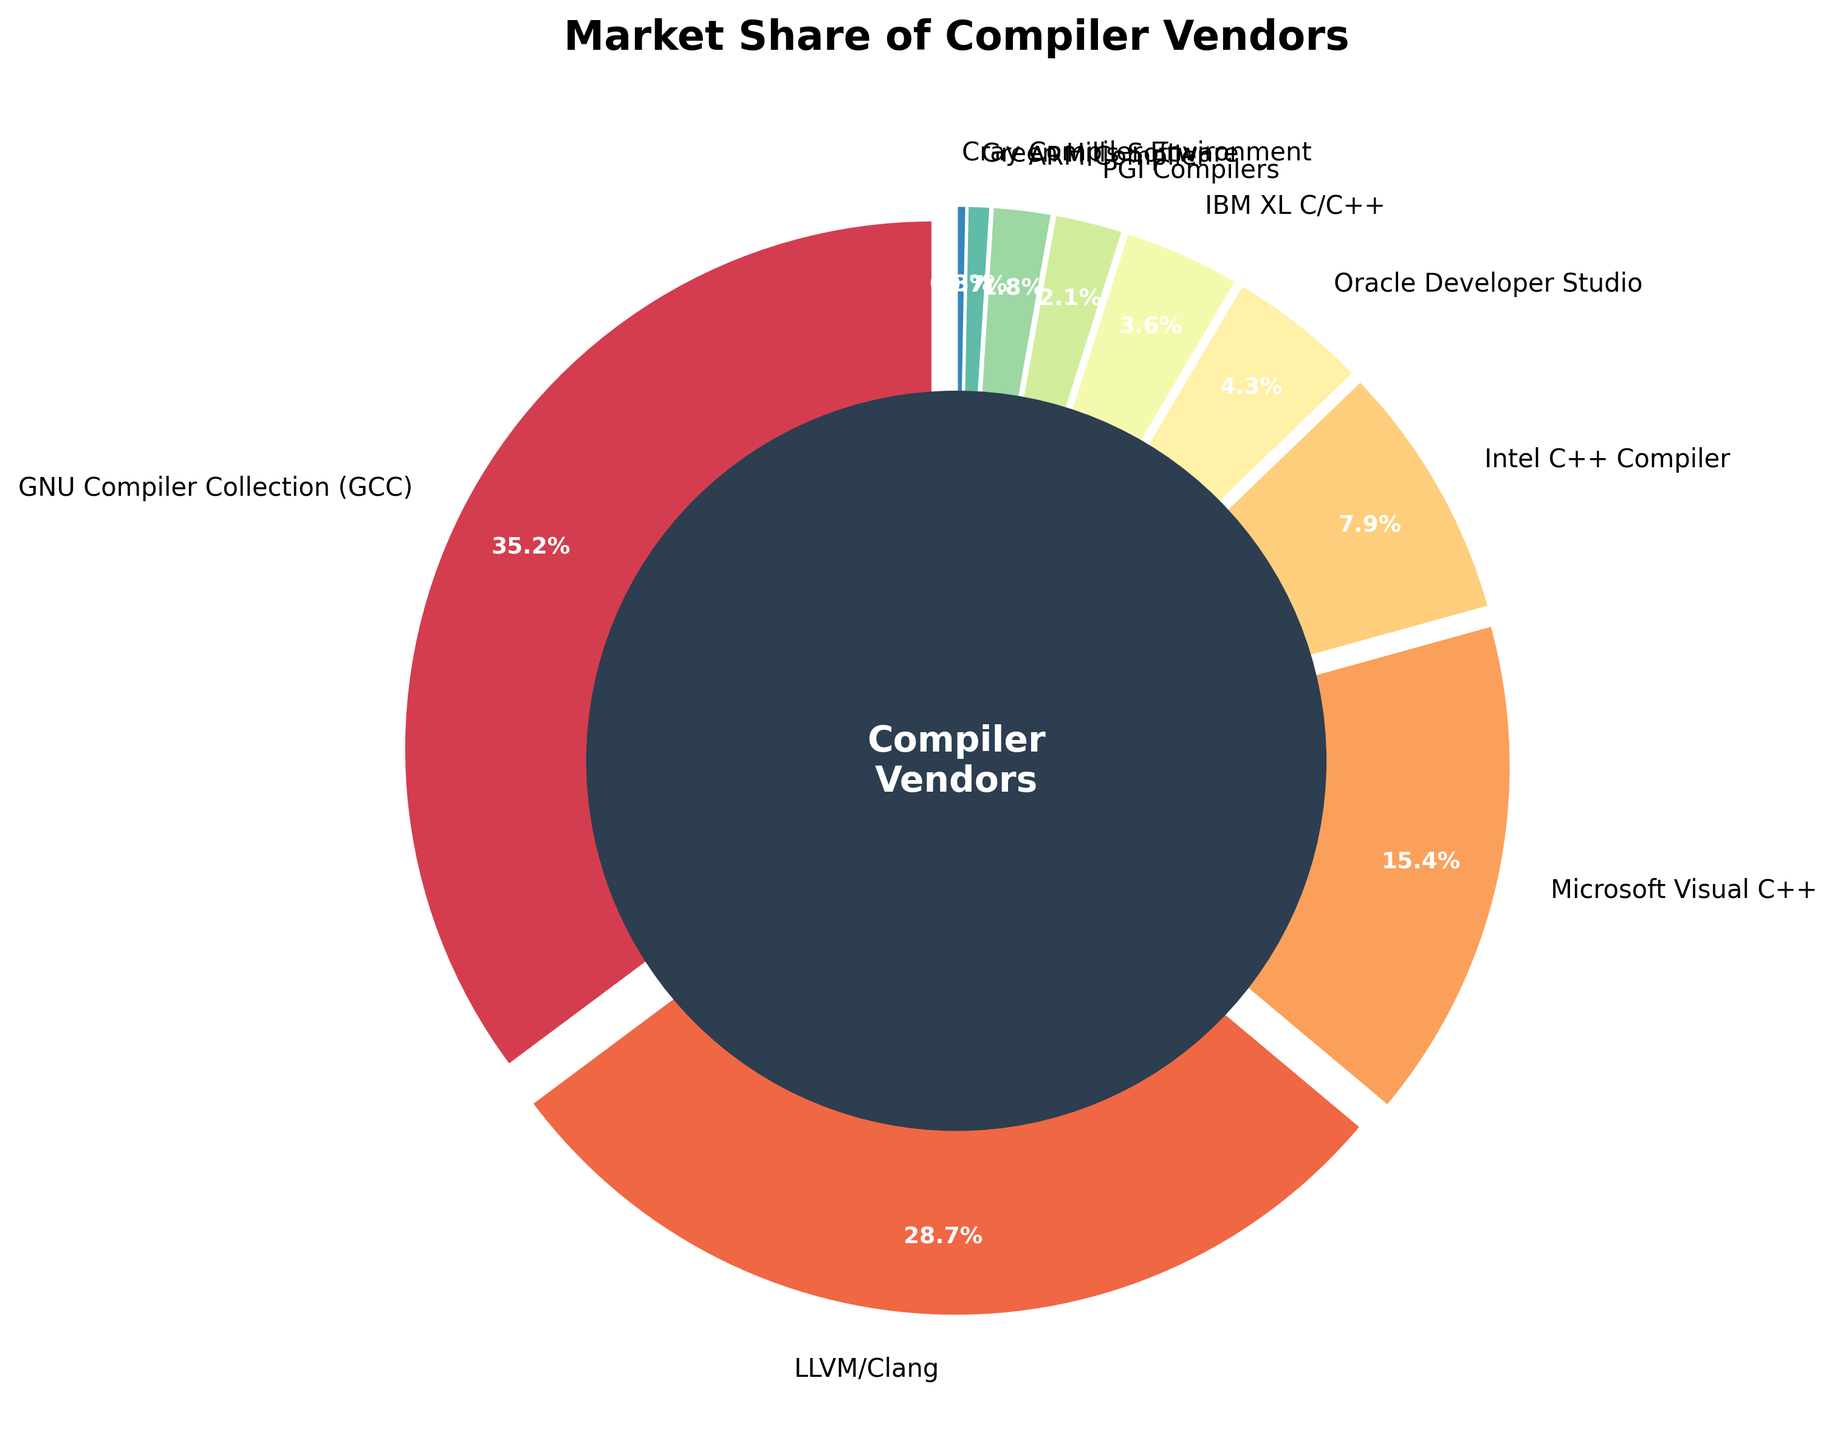What percentage of the market share is taken by GCC and LLVM/Clang together? GCC has a market share of 35.2% and LLVM/Clang has 28.7%. Adding these together gives 35.2 + 28.7 = 63.9%.
Answer: 63.9% Which compiler vendor has the smallest market share? By observing the pie chart, Cray Compiler Environment holds the smallest market share at 0.3%.
Answer: Cray Compiler Environment What is the difference in market share between Microsoft Visual C++ and Intel C++ Compiler? Microsoft Visual C++ has a market share of 15.4%, and Intel C++ Compiler has 7.9%. The difference is 15.4 - 7.9 = 7.5%.
Answer: 7.5% How do the market shares of Oracle Developer Studio and IBM XL C/C++ compare? Oracle Developer Studio has 4.3% and IBM XL C/C++ has 3.6%. Oracle Developer Studio's share is larger by 4.3 - 3.6 = 0.7%.
Answer: Oracle Developer Studio's share is larger by 0.7% What portion of the market is held by vendors other than GCC and LLVM/Clang? GCC and LLVM/Clang together hold 63.9% of the market share, so the rest is 100 - 63.9 = 36.1%.
Answer: 36.1% Which three compiler vendors have the largest market shares, and what are their individual shares? The vendors with the largest shares are GCC (35.2%), LLVM/Clang (28.7%), and Microsoft Visual C++ (15.4%).
Answer: GCC: 35.2%, LLVM/Clang: 28.7%, Microsoft Visual C++: 15.4% By how much is the market share of Green Hills Software smaller than ARM Compiler's share? ARM Compiler has a market share of 1.8%, and Green Hills Software has 0.7%. The difference is 1.8 - 0.7 = 1.1%.
Answer: 1.1% What is the total market share of the bottom four vendors? The bottom four vendors, based on market share, are PGI Compilers (2.1%), ARM Compiler (1.8%), Green Hills Software (0.7%), and Cray Compiler Environment (0.3%). Adding these gives 2.1 + 1.8 + 0.7 + 0.3 = 4.9%.
Answer: 4.9% What color represents Oracle Developer Studio in the pie chart? By observing the color legend of the pie chart, Oracle Developer Studio is represented by a specific color (please check the actual chart for the exact color).
Answer: Please check the chart 